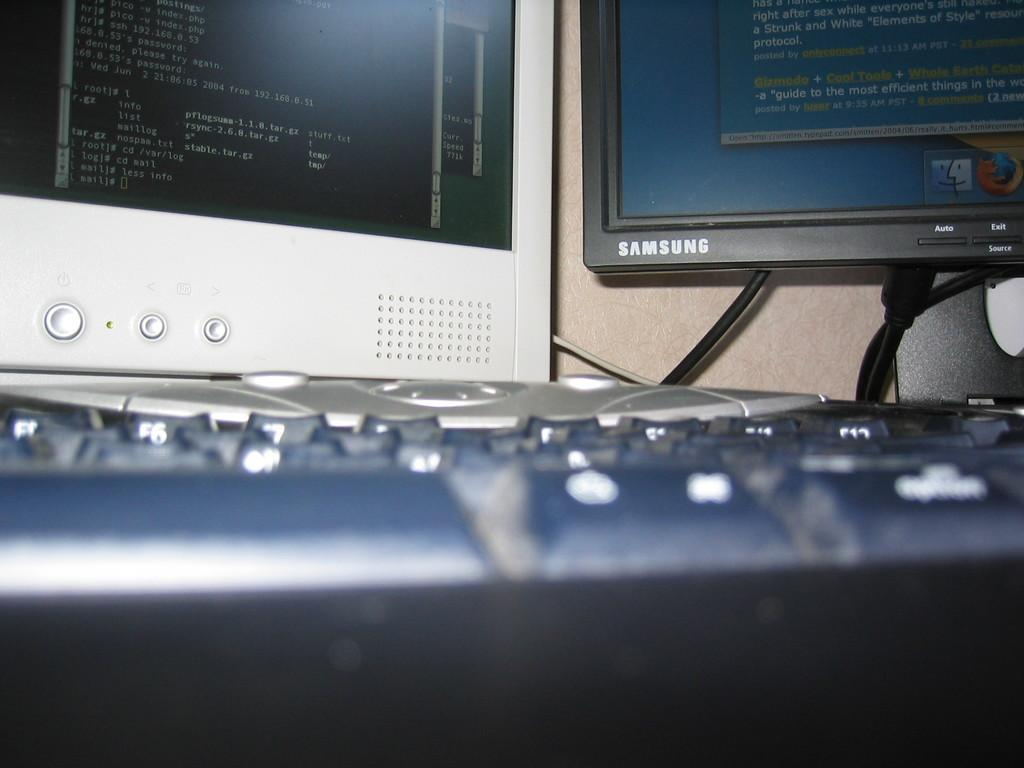<image>
Render a clear and concise summary of the photo. Two monitors, one of them samsung,  in front of a keyboard 